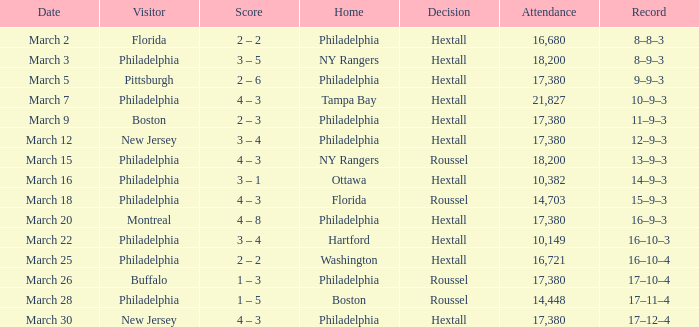Date of march 30 involves what home? Philadelphia. 